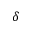Convert formula to latex. <formula><loc_0><loc_0><loc_500><loc_500>\delta</formula> 